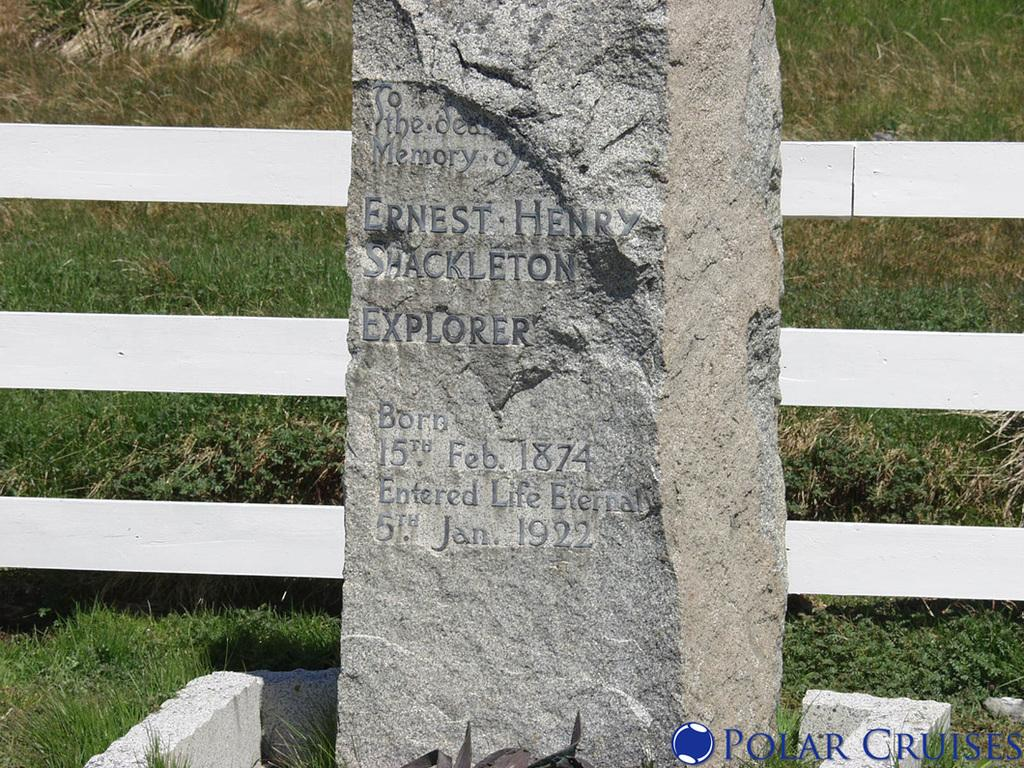What type of structure can be seen in the image? There is a gravestone in the image. What object is made of wood and visible in the image? There is a wooden grill in the image. What type of vegetation is present in the image? Grass is present in the image. What type of soup is being served on the gravestone in the image? There is no soup present in the image, and the gravestone is not serving any food. 